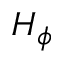Convert formula to latex. <formula><loc_0><loc_0><loc_500><loc_500>H _ { \phi }</formula> 